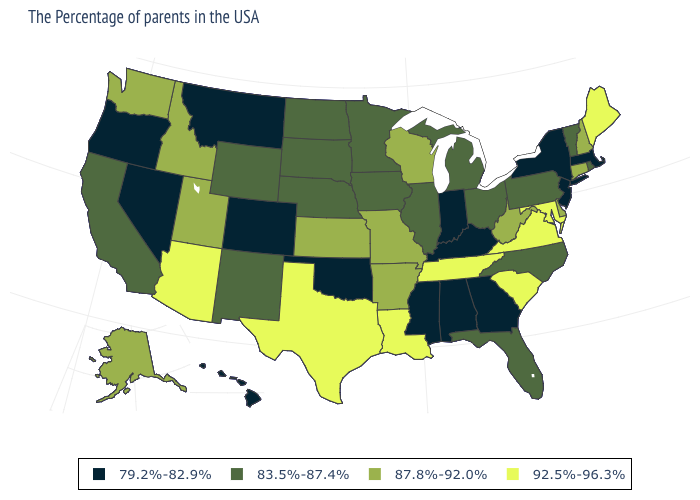What is the highest value in the USA?
Keep it brief. 92.5%-96.3%. What is the value of Vermont?
Answer briefly. 83.5%-87.4%. Which states hav the highest value in the MidWest?
Answer briefly. Wisconsin, Missouri, Kansas. Among the states that border Montana , which have the lowest value?
Give a very brief answer. South Dakota, North Dakota, Wyoming. Name the states that have a value in the range 87.8%-92.0%?
Write a very short answer. New Hampshire, Connecticut, Delaware, West Virginia, Wisconsin, Missouri, Arkansas, Kansas, Utah, Idaho, Washington, Alaska. Which states have the lowest value in the USA?
Give a very brief answer. Massachusetts, New York, New Jersey, Georgia, Kentucky, Indiana, Alabama, Mississippi, Oklahoma, Colorado, Montana, Nevada, Oregon, Hawaii. Does Nebraska have the lowest value in the USA?
Answer briefly. No. Does the first symbol in the legend represent the smallest category?
Concise answer only. Yes. What is the value of North Dakota?
Write a very short answer. 83.5%-87.4%. Does the first symbol in the legend represent the smallest category?
Give a very brief answer. Yes. How many symbols are there in the legend?
Concise answer only. 4. What is the value of New York?
Be succinct. 79.2%-82.9%. Does Washington have the same value as Maryland?
Write a very short answer. No. Does the map have missing data?
Answer briefly. No. Among the states that border Rhode Island , which have the lowest value?
Concise answer only. Massachusetts. 